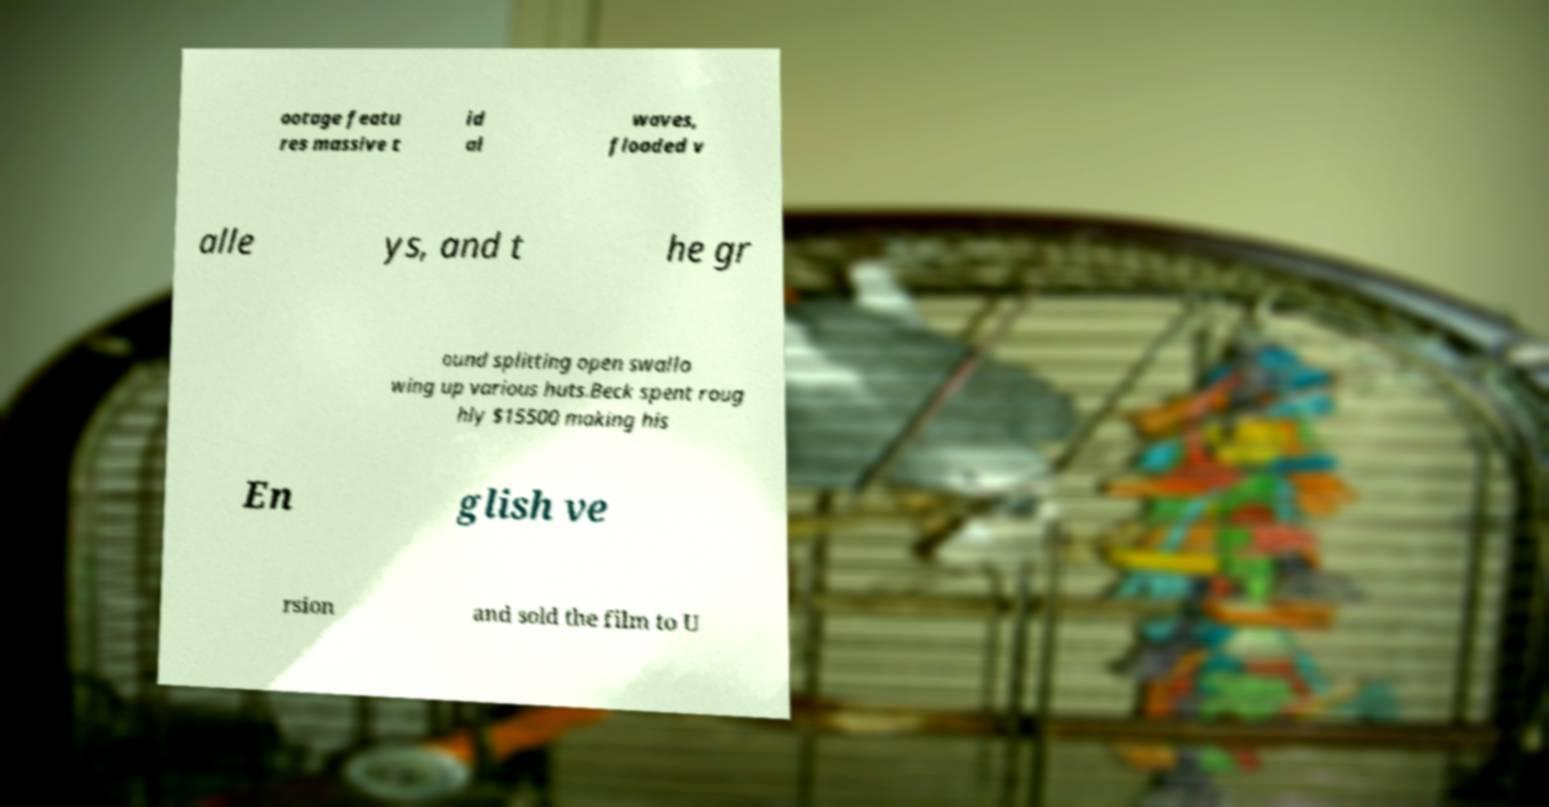Could you extract and type out the text from this image? ootage featu res massive t id al waves, flooded v alle ys, and t he gr ound splitting open swallo wing up various huts.Beck spent roug hly $15500 making his En glish ve rsion and sold the film to U 